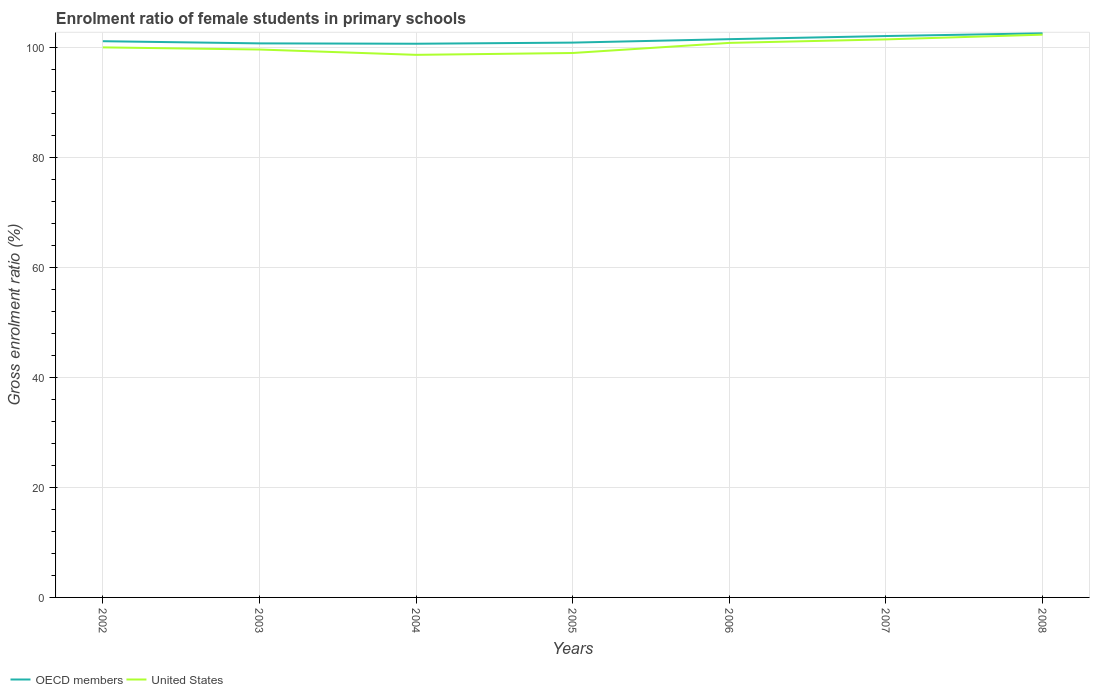Does the line corresponding to United States intersect with the line corresponding to OECD members?
Your response must be concise. No. Is the number of lines equal to the number of legend labels?
Ensure brevity in your answer.  Yes. Across all years, what is the maximum enrolment ratio of female students in primary schools in United States?
Provide a short and direct response. 98.64. What is the total enrolment ratio of female students in primary schools in OECD members in the graph?
Your answer should be very brief. -0.94. What is the difference between the highest and the second highest enrolment ratio of female students in primary schools in United States?
Ensure brevity in your answer.  3.67. What is the difference between the highest and the lowest enrolment ratio of female students in primary schools in United States?
Your answer should be compact. 3. How many lines are there?
Your answer should be very brief. 2. How many years are there in the graph?
Keep it short and to the point. 7. Where does the legend appear in the graph?
Ensure brevity in your answer.  Bottom left. How many legend labels are there?
Your response must be concise. 2. What is the title of the graph?
Offer a terse response. Enrolment ratio of female students in primary schools. What is the label or title of the Y-axis?
Offer a very short reply. Gross enrolment ratio (%). What is the Gross enrolment ratio (%) in OECD members in 2002?
Your answer should be very brief. 101.11. What is the Gross enrolment ratio (%) of United States in 2002?
Provide a succinct answer. 99.99. What is the Gross enrolment ratio (%) in OECD members in 2003?
Offer a very short reply. 100.72. What is the Gross enrolment ratio (%) of United States in 2003?
Provide a short and direct response. 99.6. What is the Gross enrolment ratio (%) of OECD members in 2004?
Provide a short and direct response. 100.66. What is the Gross enrolment ratio (%) of United States in 2004?
Provide a short and direct response. 98.64. What is the Gross enrolment ratio (%) in OECD members in 2005?
Offer a very short reply. 100.86. What is the Gross enrolment ratio (%) in United States in 2005?
Your answer should be very brief. 98.97. What is the Gross enrolment ratio (%) in OECD members in 2006?
Make the answer very short. 101.48. What is the Gross enrolment ratio (%) of United States in 2006?
Your response must be concise. 100.81. What is the Gross enrolment ratio (%) of OECD members in 2007?
Give a very brief answer. 102.05. What is the Gross enrolment ratio (%) of United States in 2007?
Give a very brief answer. 101.45. What is the Gross enrolment ratio (%) of OECD members in 2008?
Give a very brief answer. 102.55. What is the Gross enrolment ratio (%) of United States in 2008?
Make the answer very short. 102.31. Across all years, what is the maximum Gross enrolment ratio (%) in OECD members?
Provide a succinct answer. 102.55. Across all years, what is the maximum Gross enrolment ratio (%) in United States?
Provide a succinct answer. 102.31. Across all years, what is the minimum Gross enrolment ratio (%) of OECD members?
Keep it short and to the point. 100.66. Across all years, what is the minimum Gross enrolment ratio (%) of United States?
Your answer should be very brief. 98.64. What is the total Gross enrolment ratio (%) in OECD members in the graph?
Provide a succinct answer. 709.44. What is the total Gross enrolment ratio (%) of United States in the graph?
Provide a short and direct response. 701.76. What is the difference between the Gross enrolment ratio (%) in OECD members in 2002 and that in 2003?
Your response must be concise. 0.4. What is the difference between the Gross enrolment ratio (%) in United States in 2002 and that in 2003?
Your response must be concise. 0.39. What is the difference between the Gross enrolment ratio (%) in OECD members in 2002 and that in 2004?
Give a very brief answer. 0.46. What is the difference between the Gross enrolment ratio (%) of United States in 2002 and that in 2004?
Make the answer very short. 1.36. What is the difference between the Gross enrolment ratio (%) of OECD members in 2002 and that in 2005?
Offer a very short reply. 0.25. What is the difference between the Gross enrolment ratio (%) in United States in 2002 and that in 2005?
Give a very brief answer. 1.02. What is the difference between the Gross enrolment ratio (%) in OECD members in 2002 and that in 2006?
Your response must be concise. -0.37. What is the difference between the Gross enrolment ratio (%) in United States in 2002 and that in 2006?
Provide a short and direct response. -0.81. What is the difference between the Gross enrolment ratio (%) of OECD members in 2002 and that in 2007?
Your answer should be compact. -0.94. What is the difference between the Gross enrolment ratio (%) in United States in 2002 and that in 2007?
Provide a succinct answer. -1.45. What is the difference between the Gross enrolment ratio (%) of OECD members in 2002 and that in 2008?
Give a very brief answer. -1.43. What is the difference between the Gross enrolment ratio (%) in United States in 2002 and that in 2008?
Offer a very short reply. -2.31. What is the difference between the Gross enrolment ratio (%) in OECD members in 2003 and that in 2004?
Make the answer very short. 0.06. What is the difference between the Gross enrolment ratio (%) in United States in 2003 and that in 2004?
Your answer should be very brief. 0.97. What is the difference between the Gross enrolment ratio (%) of OECD members in 2003 and that in 2005?
Your response must be concise. -0.14. What is the difference between the Gross enrolment ratio (%) in United States in 2003 and that in 2005?
Ensure brevity in your answer.  0.63. What is the difference between the Gross enrolment ratio (%) of OECD members in 2003 and that in 2006?
Your answer should be compact. -0.76. What is the difference between the Gross enrolment ratio (%) in United States in 2003 and that in 2006?
Your response must be concise. -1.2. What is the difference between the Gross enrolment ratio (%) of OECD members in 2003 and that in 2007?
Provide a succinct answer. -1.34. What is the difference between the Gross enrolment ratio (%) of United States in 2003 and that in 2007?
Provide a short and direct response. -1.84. What is the difference between the Gross enrolment ratio (%) in OECD members in 2003 and that in 2008?
Give a very brief answer. -1.83. What is the difference between the Gross enrolment ratio (%) in United States in 2003 and that in 2008?
Your answer should be compact. -2.7. What is the difference between the Gross enrolment ratio (%) of OECD members in 2004 and that in 2005?
Give a very brief answer. -0.2. What is the difference between the Gross enrolment ratio (%) of United States in 2004 and that in 2005?
Your answer should be very brief. -0.34. What is the difference between the Gross enrolment ratio (%) of OECD members in 2004 and that in 2006?
Provide a succinct answer. -0.83. What is the difference between the Gross enrolment ratio (%) of United States in 2004 and that in 2006?
Ensure brevity in your answer.  -2.17. What is the difference between the Gross enrolment ratio (%) of OECD members in 2004 and that in 2007?
Give a very brief answer. -1.4. What is the difference between the Gross enrolment ratio (%) of United States in 2004 and that in 2007?
Offer a terse response. -2.81. What is the difference between the Gross enrolment ratio (%) of OECD members in 2004 and that in 2008?
Provide a short and direct response. -1.89. What is the difference between the Gross enrolment ratio (%) of United States in 2004 and that in 2008?
Give a very brief answer. -3.67. What is the difference between the Gross enrolment ratio (%) of OECD members in 2005 and that in 2006?
Keep it short and to the point. -0.62. What is the difference between the Gross enrolment ratio (%) in United States in 2005 and that in 2006?
Give a very brief answer. -1.84. What is the difference between the Gross enrolment ratio (%) of OECD members in 2005 and that in 2007?
Your answer should be very brief. -1.19. What is the difference between the Gross enrolment ratio (%) in United States in 2005 and that in 2007?
Your answer should be very brief. -2.47. What is the difference between the Gross enrolment ratio (%) in OECD members in 2005 and that in 2008?
Ensure brevity in your answer.  -1.69. What is the difference between the Gross enrolment ratio (%) in United States in 2005 and that in 2008?
Provide a short and direct response. -3.33. What is the difference between the Gross enrolment ratio (%) of OECD members in 2006 and that in 2007?
Keep it short and to the point. -0.57. What is the difference between the Gross enrolment ratio (%) in United States in 2006 and that in 2007?
Your answer should be very brief. -0.64. What is the difference between the Gross enrolment ratio (%) in OECD members in 2006 and that in 2008?
Offer a very short reply. -1.06. What is the difference between the Gross enrolment ratio (%) of United States in 2006 and that in 2008?
Offer a terse response. -1.5. What is the difference between the Gross enrolment ratio (%) of OECD members in 2007 and that in 2008?
Offer a very short reply. -0.49. What is the difference between the Gross enrolment ratio (%) in United States in 2007 and that in 2008?
Keep it short and to the point. -0.86. What is the difference between the Gross enrolment ratio (%) of OECD members in 2002 and the Gross enrolment ratio (%) of United States in 2003?
Your response must be concise. 1.51. What is the difference between the Gross enrolment ratio (%) in OECD members in 2002 and the Gross enrolment ratio (%) in United States in 2004?
Ensure brevity in your answer.  2.48. What is the difference between the Gross enrolment ratio (%) in OECD members in 2002 and the Gross enrolment ratio (%) in United States in 2005?
Offer a terse response. 2.14. What is the difference between the Gross enrolment ratio (%) in OECD members in 2002 and the Gross enrolment ratio (%) in United States in 2006?
Provide a short and direct response. 0.31. What is the difference between the Gross enrolment ratio (%) of OECD members in 2002 and the Gross enrolment ratio (%) of United States in 2007?
Your answer should be very brief. -0.33. What is the difference between the Gross enrolment ratio (%) of OECD members in 2002 and the Gross enrolment ratio (%) of United States in 2008?
Offer a terse response. -1.19. What is the difference between the Gross enrolment ratio (%) in OECD members in 2003 and the Gross enrolment ratio (%) in United States in 2004?
Give a very brief answer. 2.08. What is the difference between the Gross enrolment ratio (%) of OECD members in 2003 and the Gross enrolment ratio (%) of United States in 2005?
Provide a short and direct response. 1.75. What is the difference between the Gross enrolment ratio (%) of OECD members in 2003 and the Gross enrolment ratio (%) of United States in 2006?
Ensure brevity in your answer.  -0.09. What is the difference between the Gross enrolment ratio (%) in OECD members in 2003 and the Gross enrolment ratio (%) in United States in 2007?
Your answer should be compact. -0.73. What is the difference between the Gross enrolment ratio (%) in OECD members in 2003 and the Gross enrolment ratio (%) in United States in 2008?
Make the answer very short. -1.59. What is the difference between the Gross enrolment ratio (%) of OECD members in 2004 and the Gross enrolment ratio (%) of United States in 2005?
Give a very brief answer. 1.68. What is the difference between the Gross enrolment ratio (%) in OECD members in 2004 and the Gross enrolment ratio (%) in United States in 2006?
Your response must be concise. -0.15. What is the difference between the Gross enrolment ratio (%) in OECD members in 2004 and the Gross enrolment ratio (%) in United States in 2007?
Offer a terse response. -0.79. What is the difference between the Gross enrolment ratio (%) in OECD members in 2004 and the Gross enrolment ratio (%) in United States in 2008?
Offer a terse response. -1.65. What is the difference between the Gross enrolment ratio (%) in OECD members in 2005 and the Gross enrolment ratio (%) in United States in 2006?
Your answer should be compact. 0.05. What is the difference between the Gross enrolment ratio (%) of OECD members in 2005 and the Gross enrolment ratio (%) of United States in 2007?
Offer a terse response. -0.58. What is the difference between the Gross enrolment ratio (%) of OECD members in 2005 and the Gross enrolment ratio (%) of United States in 2008?
Provide a succinct answer. -1.44. What is the difference between the Gross enrolment ratio (%) of OECD members in 2006 and the Gross enrolment ratio (%) of United States in 2007?
Offer a terse response. 0.04. What is the difference between the Gross enrolment ratio (%) in OECD members in 2006 and the Gross enrolment ratio (%) in United States in 2008?
Make the answer very short. -0.82. What is the difference between the Gross enrolment ratio (%) of OECD members in 2007 and the Gross enrolment ratio (%) of United States in 2008?
Your answer should be very brief. -0.25. What is the average Gross enrolment ratio (%) of OECD members per year?
Your answer should be very brief. 101.35. What is the average Gross enrolment ratio (%) in United States per year?
Your answer should be very brief. 100.25. In the year 2002, what is the difference between the Gross enrolment ratio (%) of OECD members and Gross enrolment ratio (%) of United States?
Give a very brief answer. 1.12. In the year 2003, what is the difference between the Gross enrolment ratio (%) in OECD members and Gross enrolment ratio (%) in United States?
Provide a short and direct response. 1.12. In the year 2004, what is the difference between the Gross enrolment ratio (%) of OECD members and Gross enrolment ratio (%) of United States?
Your answer should be compact. 2.02. In the year 2005, what is the difference between the Gross enrolment ratio (%) in OECD members and Gross enrolment ratio (%) in United States?
Your answer should be compact. 1.89. In the year 2006, what is the difference between the Gross enrolment ratio (%) in OECD members and Gross enrolment ratio (%) in United States?
Provide a succinct answer. 0.68. In the year 2007, what is the difference between the Gross enrolment ratio (%) of OECD members and Gross enrolment ratio (%) of United States?
Your answer should be compact. 0.61. In the year 2008, what is the difference between the Gross enrolment ratio (%) of OECD members and Gross enrolment ratio (%) of United States?
Keep it short and to the point. 0.24. What is the ratio of the Gross enrolment ratio (%) in OECD members in 2002 to that in 2004?
Offer a very short reply. 1. What is the ratio of the Gross enrolment ratio (%) in United States in 2002 to that in 2004?
Offer a terse response. 1.01. What is the ratio of the Gross enrolment ratio (%) in United States in 2002 to that in 2005?
Offer a terse response. 1.01. What is the ratio of the Gross enrolment ratio (%) of OECD members in 2002 to that in 2006?
Provide a short and direct response. 1. What is the ratio of the Gross enrolment ratio (%) in OECD members in 2002 to that in 2007?
Make the answer very short. 0.99. What is the ratio of the Gross enrolment ratio (%) in United States in 2002 to that in 2007?
Keep it short and to the point. 0.99. What is the ratio of the Gross enrolment ratio (%) of OECD members in 2002 to that in 2008?
Give a very brief answer. 0.99. What is the ratio of the Gross enrolment ratio (%) in United States in 2002 to that in 2008?
Offer a terse response. 0.98. What is the ratio of the Gross enrolment ratio (%) in OECD members in 2003 to that in 2004?
Your answer should be compact. 1. What is the ratio of the Gross enrolment ratio (%) in United States in 2003 to that in 2004?
Ensure brevity in your answer.  1.01. What is the ratio of the Gross enrolment ratio (%) in OECD members in 2003 to that in 2005?
Give a very brief answer. 1. What is the ratio of the Gross enrolment ratio (%) in United States in 2003 to that in 2005?
Provide a short and direct response. 1.01. What is the ratio of the Gross enrolment ratio (%) in United States in 2003 to that in 2006?
Give a very brief answer. 0.99. What is the ratio of the Gross enrolment ratio (%) in OECD members in 2003 to that in 2007?
Provide a short and direct response. 0.99. What is the ratio of the Gross enrolment ratio (%) of United States in 2003 to that in 2007?
Make the answer very short. 0.98. What is the ratio of the Gross enrolment ratio (%) in OECD members in 2003 to that in 2008?
Ensure brevity in your answer.  0.98. What is the ratio of the Gross enrolment ratio (%) of United States in 2003 to that in 2008?
Provide a short and direct response. 0.97. What is the ratio of the Gross enrolment ratio (%) of United States in 2004 to that in 2005?
Ensure brevity in your answer.  1. What is the ratio of the Gross enrolment ratio (%) in United States in 2004 to that in 2006?
Your response must be concise. 0.98. What is the ratio of the Gross enrolment ratio (%) in OECD members in 2004 to that in 2007?
Your answer should be compact. 0.99. What is the ratio of the Gross enrolment ratio (%) in United States in 2004 to that in 2007?
Ensure brevity in your answer.  0.97. What is the ratio of the Gross enrolment ratio (%) in OECD members in 2004 to that in 2008?
Make the answer very short. 0.98. What is the ratio of the Gross enrolment ratio (%) in United States in 2004 to that in 2008?
Your response must be concise. 0.96. What is the ratio of the Gross enrolment ratio (%) in OECD members in 2005 to that in 2006?
Offer a terse response. 0.99. What is the ratio of the Gross enrolment ratio (%) of United States in 2005 to that in 2006?
Your response must be concise. 0.98. What is the ratio of the Gross enrolment ratio (%) of OECD members in 2005 to that in 2007?
Ensure brevity in your answer.  0.99. What is the ratio of the Gross enrolment ratio (%) of United States in 2005 to that in 2007?
Give a very brief answer. 0.98. What is the ratio of the Gross enrolment ratio (%) in OECD members in 2005 to that in 2008?
Give a very brief answer. 0.98. What is the ratio of the Gross enrolment ratio (%) of United States in 2005 to that in 2008?
Make the answer very short. 0.97. What is the ratio of the Gross enrolment ratio (%) of United States in 2006 to that in 2007?
Your answer should be compact. 0.99. What is the ratio of the Gross enrolment ratio (%) in United States in 2006 to that in 2008?
Your response must be concise. 0.99. What is the difference between the highest and the second highest Gross enrolment ratio (%) of OECD members?
Offer a very short reply. 0.49. What is the difference between the highest and the second highest Gross enrolment ratio (%) of United States?
Offer a terse response. 0.86. What is the difference between the highest and the lowest Gross enrolment ratio (%) of OECD members?
Your answer should be very brief. 1.89. What is the difference between the highest and the lowest Gross enrolment ratio (%) in United States?
Keep it short and to the point. 3.67. 